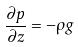Convert formula to latex. <formula><loc_0><loc_0><loc_500><loc_500>\frac { \partial p } { \partial z } = - \rho g</formula> 